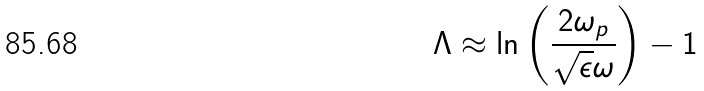<formula> <loc_0><loc_0><loc_500><loc_500>\Lambda \approx \ln \left ( \frac { 2 \omega _ { p } } { \sqrt { \epsilon } \omega } \right ) - 1</formula> 